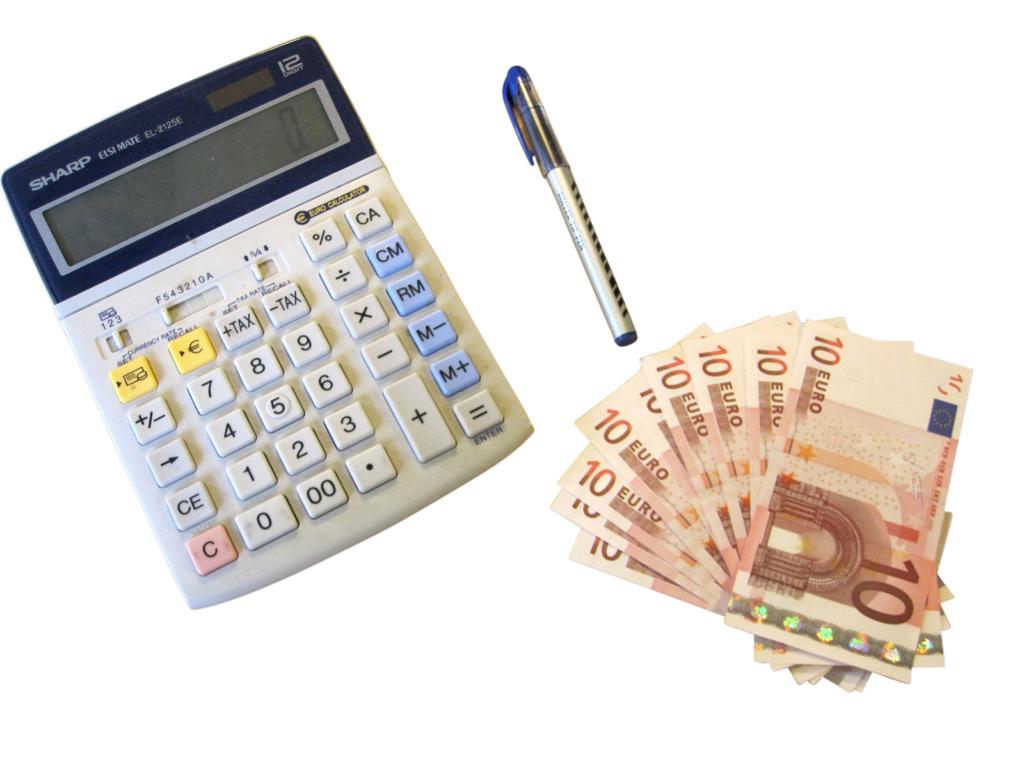What currency is the money?
Your answer should be compact. Euro. Is the currency all 10 euro?
Offer a very short reply. Yes. 